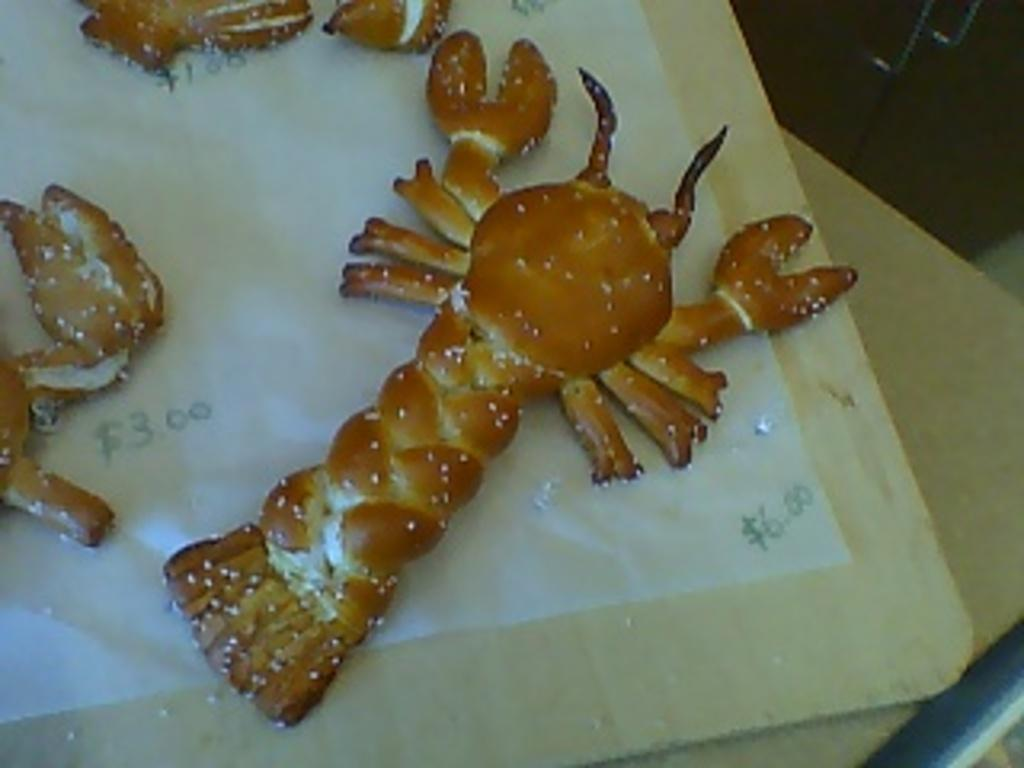What type of objects can be seen in the image? There are food items in the image. Can you describe the surface on which the food items are placed? The food items are on a wooden surface. How does the feeling of the food items change throughout the day in the image? The image does not depict any feelings or emotions associated with the food items; it only shows their physical appearance. 